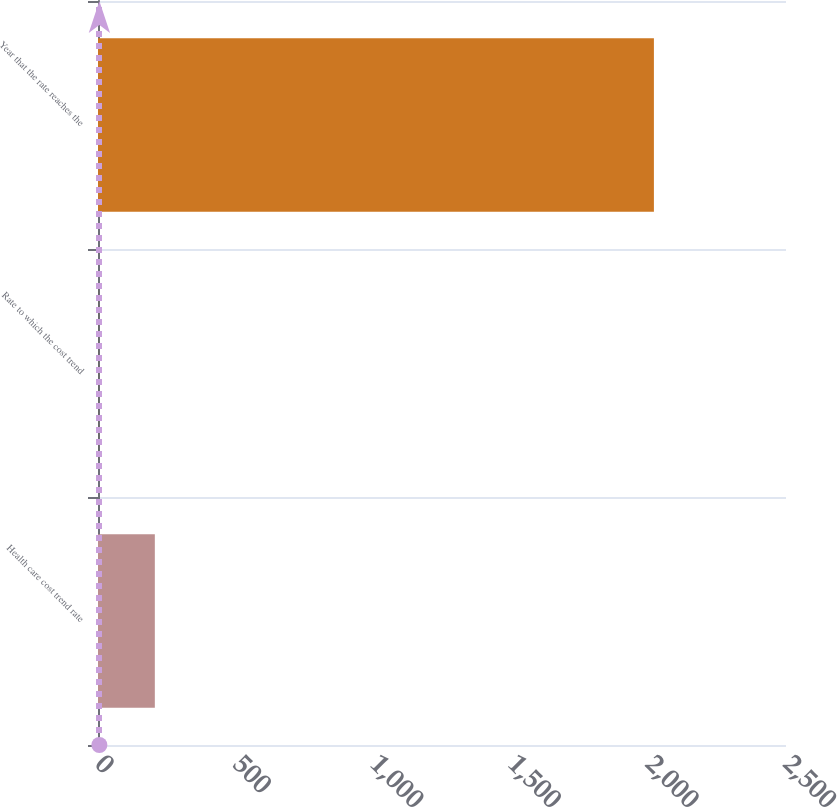Convert chart. <chart><loc_0><loc_0><loc_500><loc_500><bar_chart><fcel>Health care cost trend rate<fcel>Rate to which the cost trend<fcel>Year that the rate reaches the<nl><fcel>206.5<fcel>5<fcel>2020<nl></chart> 